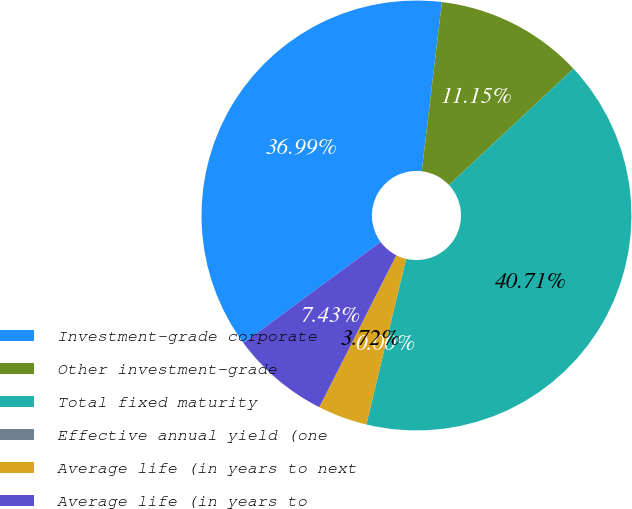<chart> <loc_0><loc_0><loc_500><loc_500><pie_chart><fcel>Investment-grade corporate<fcel>Other investment-grade<fcel>Total fixed maturity<fcel>Effective annual yield (one<fcel>Average life (in years to next<fcel>Average life (in years to<nl><fcel>36.99%<fcel>11.15%<fcel>40.71%<fcel>0.0%<fcel>3.72%<fcel>7.43%<nl></chart> 